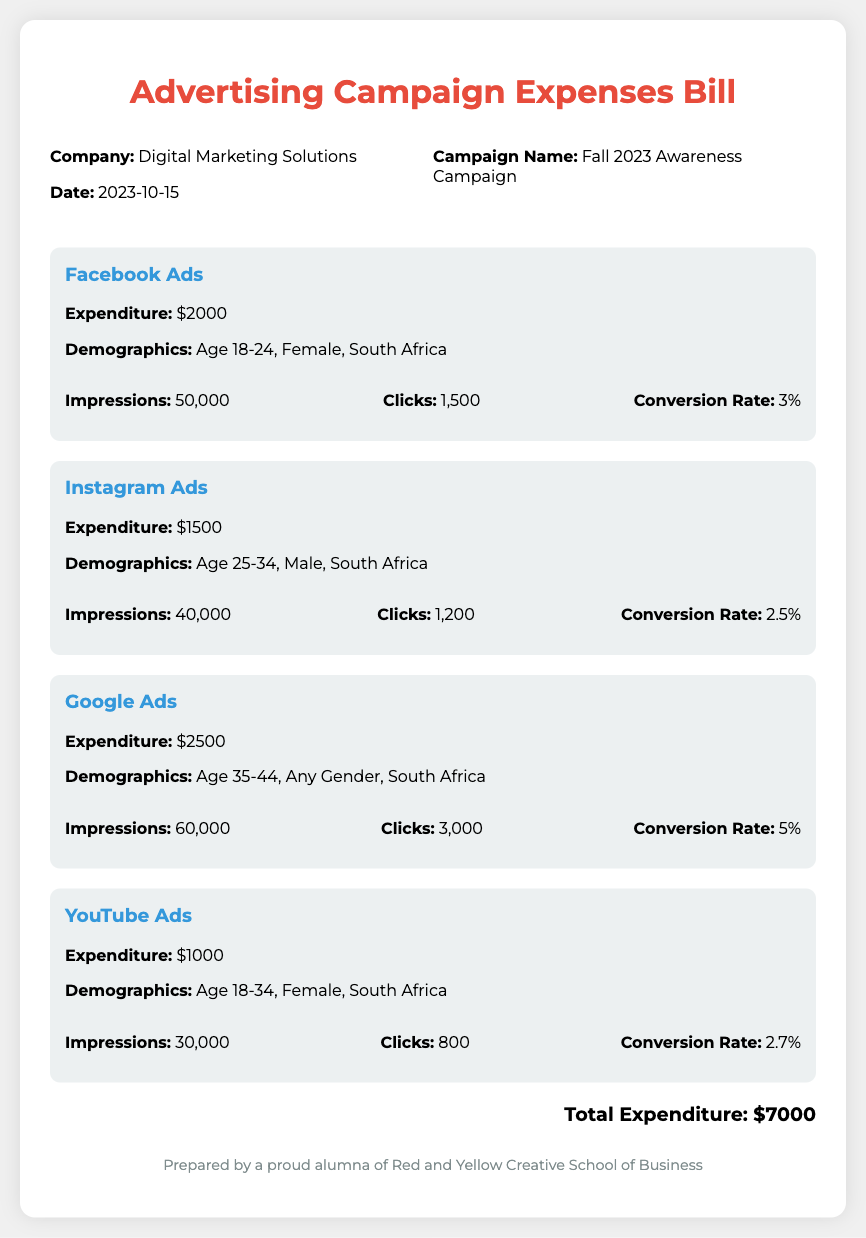What is the total expenditure? The total expenditure is the sum of expenditures across all platforms listed in the document.
Answer: $7000 What is the campaign name? The campaign name is stated in the header section of the document.
Answer: Fall 2023 Awareness Campaign What is the expenditure for Google Ads? The expenditure for Google Ads is specifically mentioned in the platform section of the document.
Answer: $2500 What age group did the Facebook Ads target? The target age group for Facebook Ads is stated in the demographics section of that platform.
Answer: Age 18-24 How many clicks did Instagram Ads receive? The number of clicks for Instagram Ads is provided in the metrics of that platform.
Answer: 1200 Which platform had the highest conversion rate? The conversion rates are compared across all platforms to determine which one is highest.
Answer: Google Ads What is the total number of impressions for YouTube Ads? The total number of impressions for YouTube Ads is mentioned in its respective platform section.
Answer: 30000 Who prepared the document? The person who prepared the document is mentioned in the footer of the bill.
Answer: A proud alumna of Red and Yellow Creative School of Business What demographic was targeted by the Google Ads? The demographic for Google Ads is stated in the platform section of the document.
Answer: Age 35-44, Any Gender, South Africa 